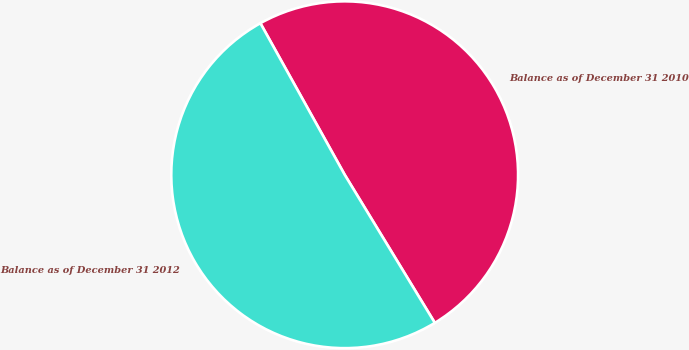Convert chart to OTSL. <chart><loc_0><loc_0><loc_500><loc_500><pie_chart><fcel>Balance as of December 31 2010<fcel>Balance as of December 31 2012<nl><fcel>49.38%<fcel>50.62%<nl></chart> 